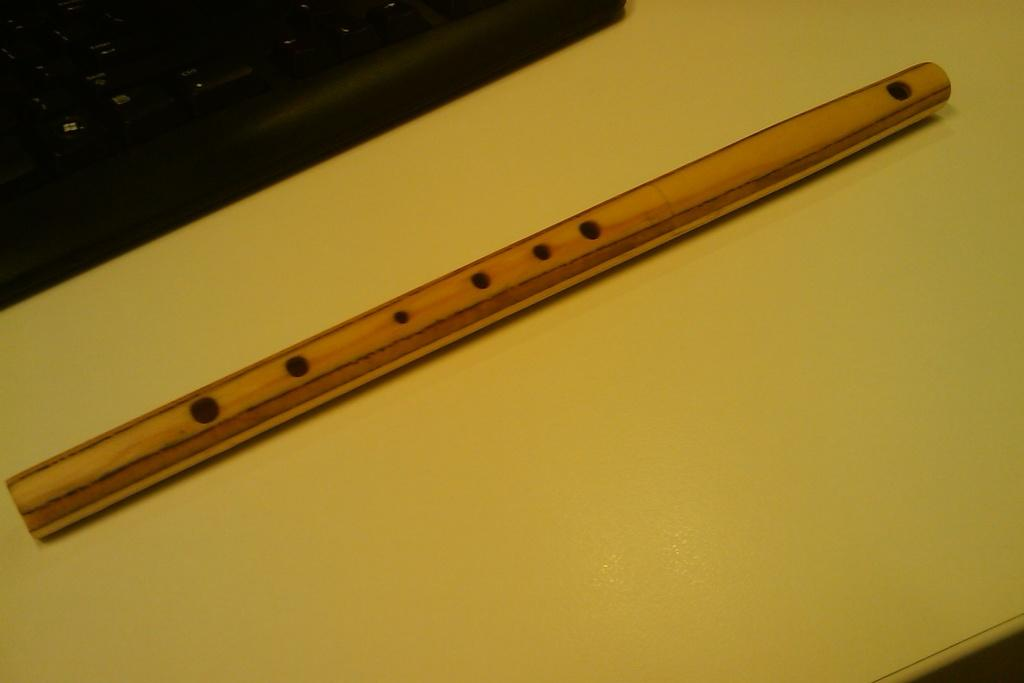What musical instrument is on the yellow surface in the image? There is a flute on a yellow surface in the image. What other musical instrument can be seen in the image? There is a keyboard in the left top corner of the image. What type of thunder can be heard in the background of the image? There is no thunder present in the image, as it is a still image of a flute and a keyboard. How many jellyfish are swimming in the yellow surface of the image? There are no jellyfish present in the image; it features a flute on a yellow surface and a keyboard in the corner. 